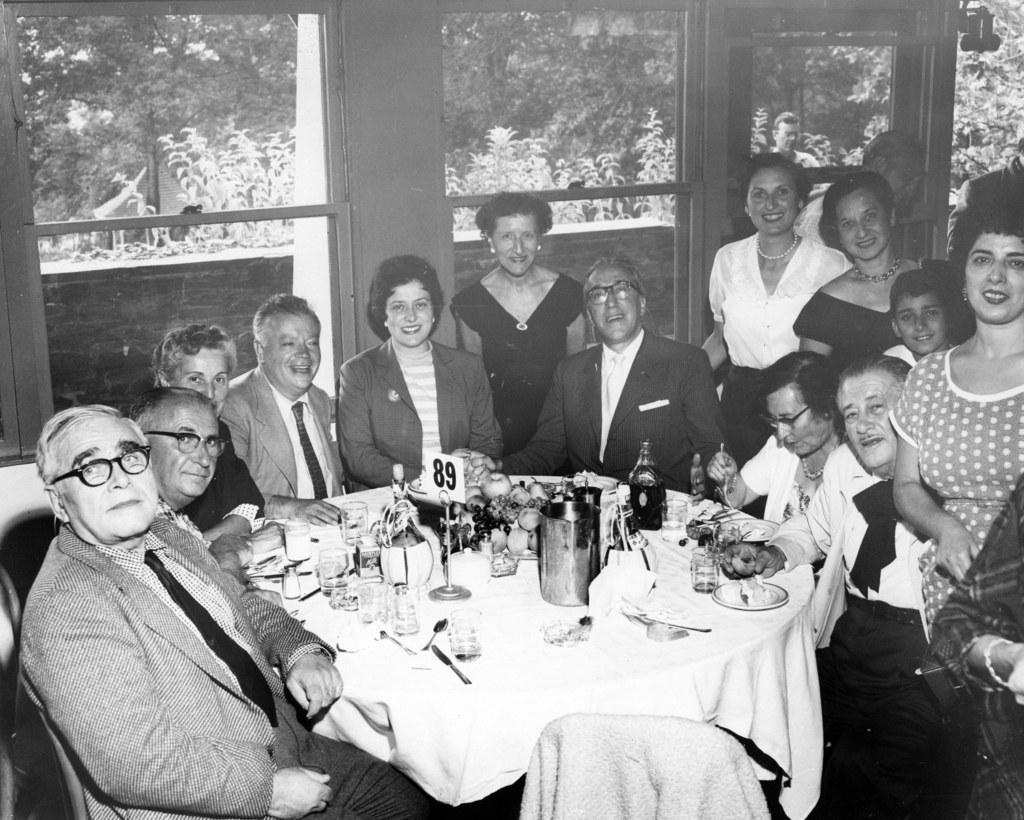Could you give a brief overview of what you see in this image? In this image we can see this people sitting around the table and this people standing near them. There are many things placed on the table. In the background we can see glass windows and trees through it. 